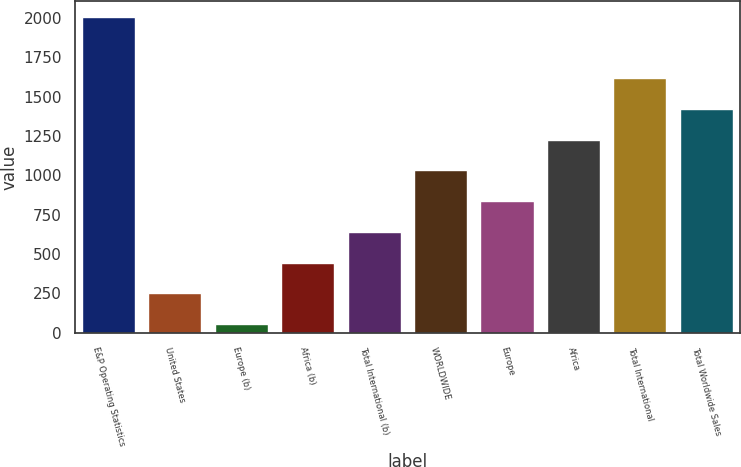<chart> <loc_0><loc_0><loc_500><loc_500><bar_chart><fcel>E&P Operating Statistics<fcel>United States<fcel>Europe (b)<fcel>Africa (b)<fcel>Total International (b)<fcel>WORLDWIDE<fcel>Europe<fcel>Africa<fcel>Total International<fcel>Total Worldwide Sales<nl><fcel>2008<fcel>250.3<fcel>55<fcel>445.6<fcel>640.9<fcel>1031.5<fcel>836.2<fcel>1226.8<fcel>1617.4<fcel>1422.1<nl></chart> 